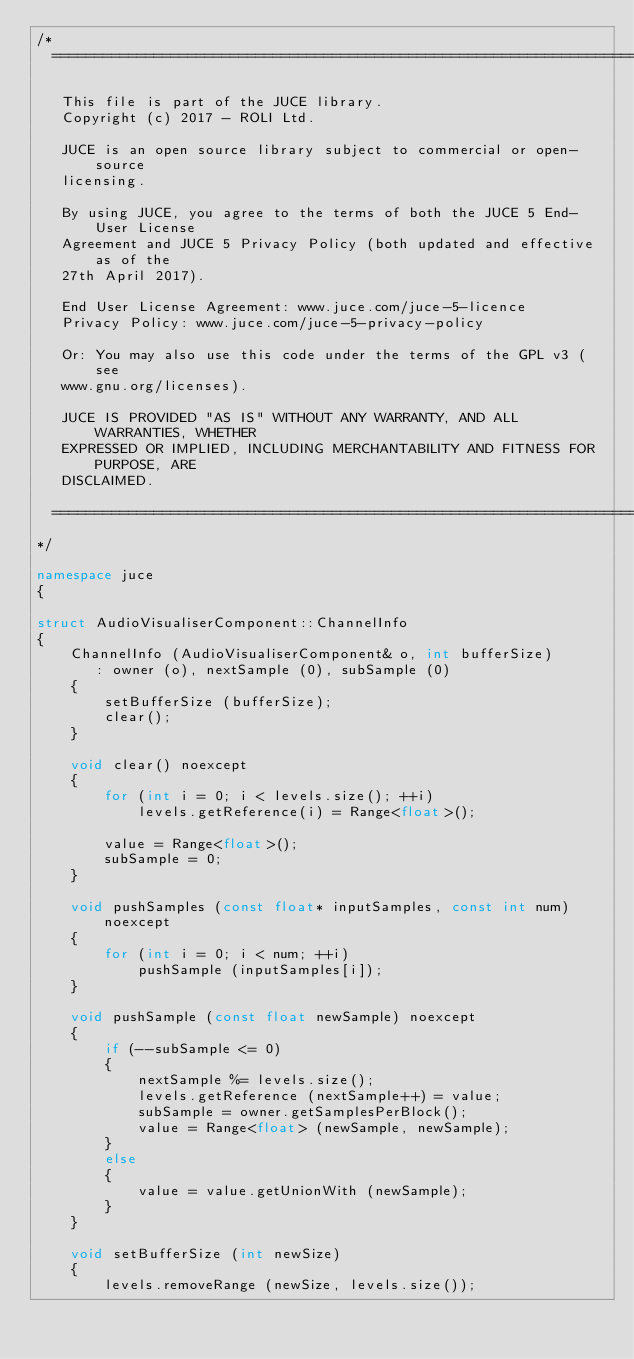<code> <loc_0><loc_0><loc_500><loc_500><_C++_>/*
  ==============================================================================

   This file is part of the JUCE library.
   Copyright (c) 2017 - ROLI Ltd.

   JUCE is an open source library subject to commercial or open-source
   licensing.

   By using JUCE, you agree to the terms of both the JUCE 5 End-User License
   Agreement and JUCE 5 Privacy Policy (both updated and effective as of the
   27th April 2017).

   End User License Agreement: www.juce.com/juce-5-licence
   Privacy Policy: www.juce.com/juce-5-privacy-policy

   Or: You may also use this code under the terms of the GPL v3 (see
   www.gnu.org/licenses).

   JUCE IS PROVIDED "AS IS" WITHOUT ANY WARRANTY, AND ALL WARRANTIES, WHETHER
   EXPRESSED OR IMPLIED, INCLUDING MERCHANTABILITY AND FITNESS FOR PURPOSE, ARE
   DISCLAIMED.

  ==============================================================================
*/

namespace juce
{

struct AudioVisualiserComponent::ChannelInfo
{
    ChannelInfo (AudioVisualiserComponent& o, int bufferSize)
       : owner (o), nextSample (0), subSample (0)
    {
        setBufferSize (bufferSize);
        clear();
    }

    void clear() noexcept
    {
        for (int i = 0; i < levels.size(); ++i)
            levels.getReference(i) = Range<float>();

        value = Range<float>();
        subSample = 0;
    }

    void pushSamples (const float* inputSamples, const int num) noexcept
    {
        for (int i = 0; i < num; ++i)
            pushSample (inputSamples[i]);
    }

    void pushSample (const float newSample) noexcept
    {
        if (--subSample <= 0)
        {
            nextSample %= levels.size();
            levels.getReference (nextSample++) = value;
            subSample = owner.getSamplesPerBlock();
            value = Range<float> (newSample, newSample);
        }
        else
        {
            value = value.getUnionWith (newSample);
        }
    }

    void setBufferSize (int newSize)
    {
        levels.removeRange (newSize, levels.size());</code> 